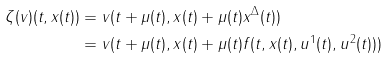<formula> <loc_0><loc_0><loc_500><loc_500>\zeta ( v ) ( t , x ( t ) ) & = v ( t + \mu ( t ) , x ( t ) + \mu ( t ) x ^ { \Delta } ( t ) ) \\ & = v ( t + \mu ( t ) , x ( t ) + \mu ( t ) f ( t , x ( t ) , u ^ { 1 } ( t ) , u ^ { 2 } ( t ) ) )</formula> 